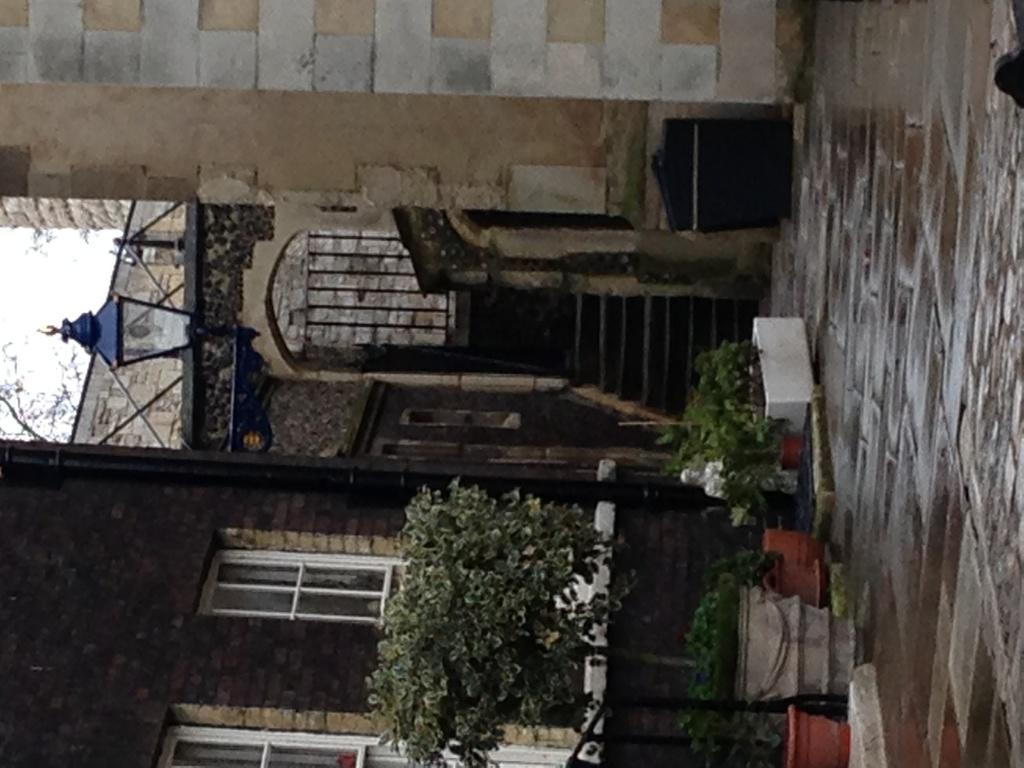What objects can be seen in the right corner of the image? There are flower vases in the right corner of the image. What type of structures are visible in the background of the image? There are buildings in the background of the image. How many eggs are present in the image? There are no eggs visible in the image. What action are the flowers performing in the image? The flowers are not performing any actions, as they are inanimate objects. 